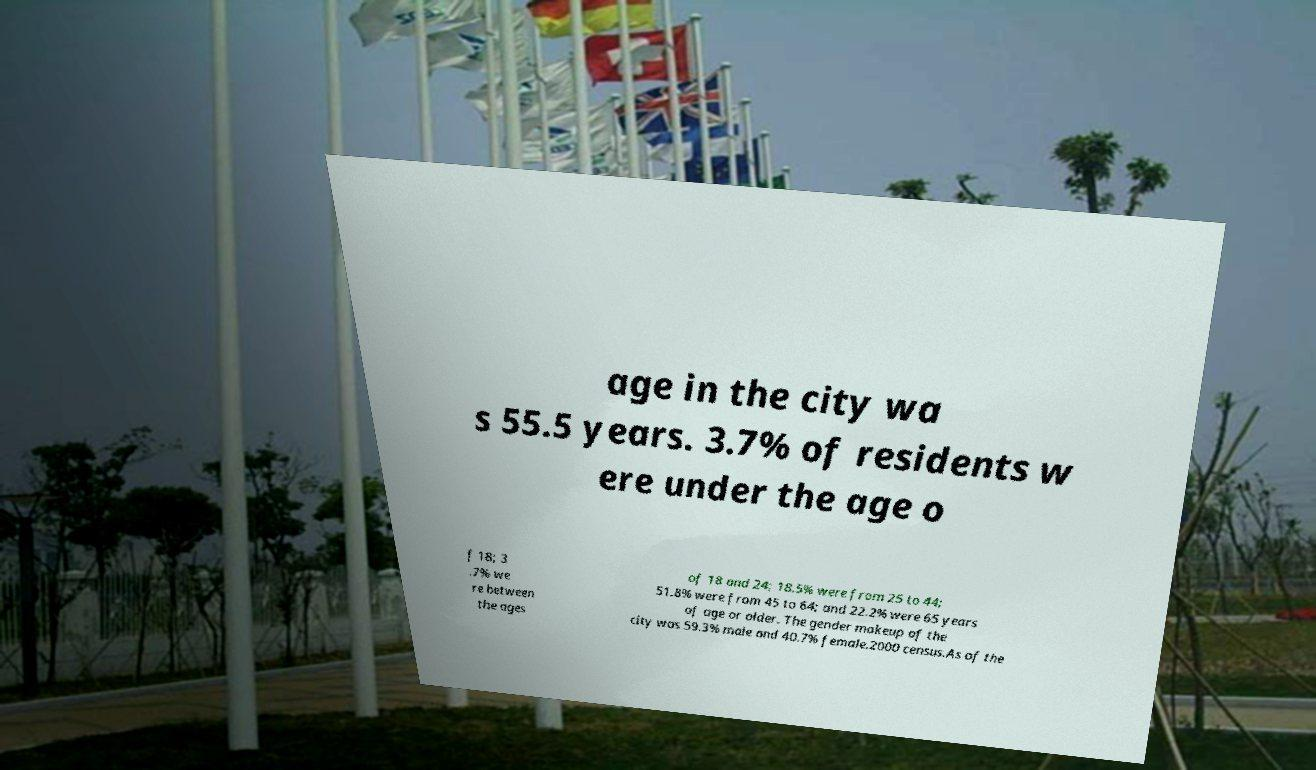Please identify and transcribe the text found in this image. age in the city wa s 55.5 years. 3.7% of residents w ere under the age o f 18; 3 .7% we re between the ages of 18 and 24; 18.5% were from 25 to 44; 51.8% were from 45 to 64; and 22.2% were 65 years of age or older. The gender makeup of the city was 59.3% male and 40.7% female.2000 census.As of the 